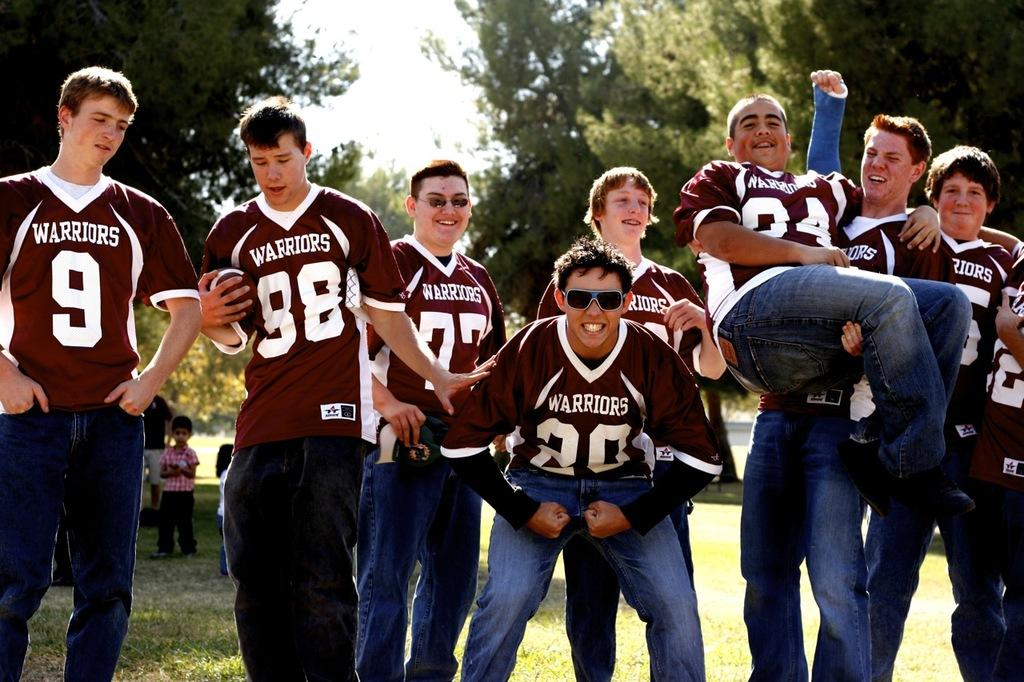<image>
Summarize the visual content of the image. A footbal team named the Warriors posing for a picture 